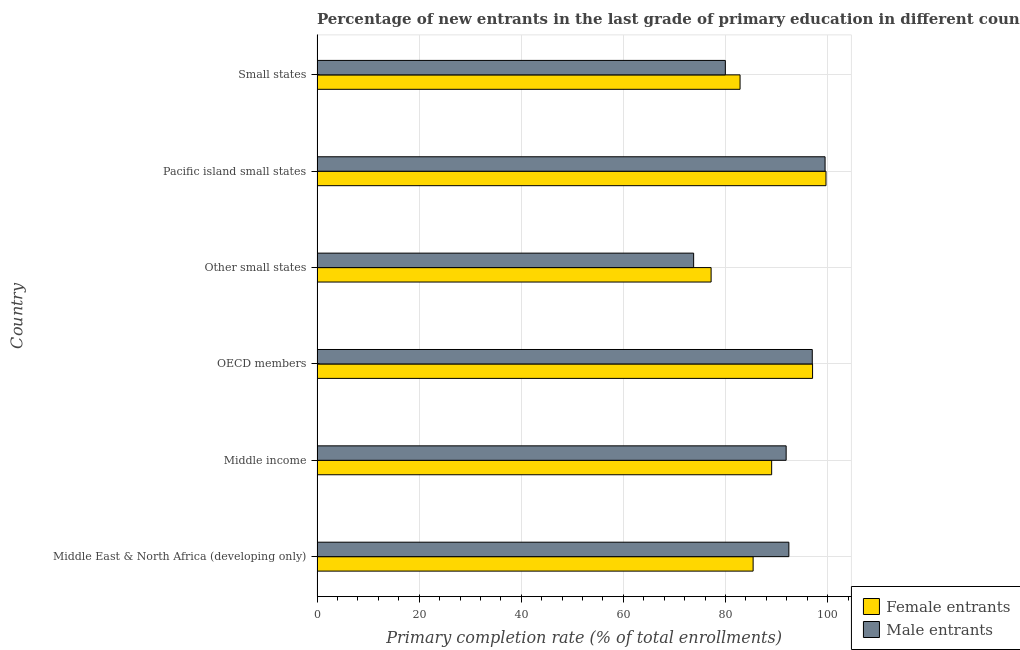How many groups of bars are there?
Provide a short and direct response. 6. How many bars are there on the 1st tick from the top?
Make the answer very short. 2. What is the label of the 3rd group of bars from the top?
Offer a very short reply. Other small states. What is the primary completion rate of male entrants in Small states?
Your response must be concise. 79.97. Across all countries, what is the maximum primary completion rate of male entrants?
Provide a short and direct response. 99.51. Across all countries, what is the minimum primary completion rate of male entrants?
Provide a succinct answer. 73.76. In which country was the primary completion rate of female entrants maximum?
Your response must be concise. Pacific island small states. In which country was the primary completion rate of female entrants minimum?
Make the answer very short. Other small states. What is the total primary completion rate of male entrants in the graph?
Give a very brief answer. 534.54. What is the difference between the primary completion rate of female entrants in Other small states and that in Pacific island small states?
Offer a terse response. -22.5. What is the difference between the primary completion rate of male entrants in Small states and the primary completion rate of female entrants in Middle East & North Africa (developing only)?
Provide a succinct answer. -5.44. What is the average primary completion rate of male entrants per country?
Provide a short and direct response. 89.09. What is the ratio of the primary completion rate of male entrants in Middle East & North Africa (developing only) to that in Small states?
Make the answer very short. 1.16. What is the difference between the highest and the second highest primary completion rate of female entrants?
Make the answer very short. 2.63. What is the difference between the highest and the lowest primary completion rate of female entrants?
Make the answer very short. 22.5. What does the 2nd bar from the top in OECD members represents?
Provide a short and direct response. Female entrants. What does the 2nd bar from the bottom in Other small states represents?
Provide a succinct answer. Male entrants. How many bars are there?
Your answer should be compact. 12. Are all the bars in the graph horizontal?
Your response must be concise. Yes. How many countries are there in the graph?
Provide a short and direct response. 6. Does the graph contain any zero values?
Give a very brief answer. No. Does the graph contain grids?
Keep it short and to the point. Yes. How many legend labels are there?
Offer a very short reply. 2. What is the title of the graph?
Ensure brevity in your answer.  Percentage of new entrants in the last grade of primary education in different countries. What is the label or title of the X-axis?
Your response must be concise. Primary completion rate (% of total enrollments). What is the label or title of the Y-axis?
Your answer should be compact. Country. What is the Primary completion rate (% of total enrollments) in Female entrants in Middle East & North Africa (developing only)?
Provide a succinct answer. 85.41. What is the Primary completion rate (% of total enrollments) of Male entrants in Middle East & North Africa (developing only)?
Provide a short and direct response. 92.41. What is the Primary completion rate (% of total enrollments) in Female entrants in Middle income?
Your answer should be compact. 89.04. What is the Primary completion rate (% of total enrollments) in Male entrants in Middle income?
Keep it short and to the point. 91.88. What is the Primary completion rate (% of total enrollments) of Female entrants in OECD members?
Keep it short and to the point. 97.05. What is the Primary completion rate (% of total enrollments) in Male entrants in OECD members?
Keep it short and to the point. 97. What is the Primary completion rate (% of total enrollments) of Female entrants in Other small states?
Offer a terse response. 77.18. What is the Primary completion rate (% of total enrollments) of Male entrants in Other small states?
Your answer should be compact. 73.76. What is the Primary completion rate (% of total enrollments) in Female entrants in Pacific island small states?
Offer a very short reply. 99.68. What is the Primary completion rate (% of total enrollments) of Male entrants in Pacific island small states?
Ensure brevity in your answer.  99.51. What is the Primary completion rate (% of total enrollments) of Female entrants in Small states?
Provide a short and direct response. 82.85. What is the Primary completion rate (% of total enrollments) of Male entrants in Small states?
Keep it short and to the point. 79.97. Across all countries, what is the maximum Primary completion rate (% of total enrollments) of Female entrants?
Give a very brief answer. 99.68. Across all countries, what is the maximum Primary completion rate (% of total enrollments) of Male entrants?
Offer a terse response. 99.51. Across all countries, what is the minimum Primary completion rate (% of total enrollments) in Female entrants?
Give a very brief answer. 77.18. Across all countries, what is the minimum Primary completion rate (% of total enrollments) of Male entrants?
Your answer should be very brief. 73.76. What is the total Primary completion rate (% of total enrollments) in Female entrants in the graph?
Your response must be concise. 531.23. What is the total Primary completion rate (% of total enrollments) in Male entrants in the graph?
Provide a short and direct response. 534.53. What is the difference between the Primary completion rate (% of total enrollments) of Female entrants in Middle East & North Africa (developing only) and that in Middle income?
Your response must be concise. -3.63. What is the difference between the Primary completion rate (% of total enrollments) in Male entrants in Middle East & North Africa (developing only) and that in Middle income?
Provide a short and direct response. 0.53. What is the difference between the Primary completion rate (% of total enrollments) in Female entrants in Middle East & North Africa (developing only) and that in OECD members?
Ensure brevity in your answer.  -11.64. What is the difference between the Primary completion rate (% of total enrollments) of Male entrants in Middle East & North Africa (developing only) and that in OECD members?
Give a very brief answer. -4.59. What is the difference between the Primary completion rate (% of total enrollments) in Female entrants in Middle East & North Africa (developing only) and that in Other small states?
Give a very brief answer. 8.23. What is the difference between the Primary completion rate (% of total enrollments) in Male entrants in Middle East & North Africa (developing only) and that in Other small states?
Ensure brevity in your answer.  18.65. What is the difference between the Primary completion rate (% of total enrollments) in Female entrants in Middle East & North Africa (developing only) and that in Pacific island small states?
Your answer should be very brief. -14.27. What is the difference between the Primary completion rate (% of total enrollments) of Male entrants in Middle East & North Africa (developing only) and that in Pacific island small states?
Provide a succinct answer. -7.09. What is the difference between the Primary completion rate (% of total enrollments) of Female entrants in Middle East & North Africa (developing only) and that in Small states?
Make the answer very short. 2.56. What is the difference between the Primary completion rate (% of total enrollments) in Male entrants in Middle East & North Africa (developing only) and that in Small states?
Provide a succinct answer. 12.44. What is the difference between the Primary completion rate (% of total enrollments) of Female entrants in Middle income and that in OECD members?
Provide a short and direct response. -8.01. What is the difference between the Primary completion rate (% of total enrollments) of Male entrants in Middle income and that in OECD members?
Your answer should be very brief. -5.12. What is the difference between the Primary completion rate (% of total enrollments) of Female entrants in Middle income and that in Other small states?
Give a very brief answer. 11.86. What is the difference between the Primary completion rate (% of total enrollments) in Male entrants in Middle income and that in Other small states?
Your answer should be compact. 18.12. What is the difference between the Primary completion rate (% of total enrollments) of Female entrants in Middle income and that in Pacific island small states?
Your answer should be very brief. -10.64. What is the difference between the Primary completion rate (% of total enrollments) in Male entrants in Middle income and that in Pacific island small states?
Keep it short and to the point. -7.62. What is the difference between the Primary completion rate (% of total enrollments) of Female entrants in Middle income and that in Small states?
Your response must be concise. 6.19. What is the difference between the Primary completion rate (% of total enrollments) of Male entrants in Middle income and that in Small states?
Give a very brief answer. 11.91. What is the difference between the Primary completion rate (% of total enrollments) of Female entrants in OECD members and that in Other small states?
Your answer should be very brief. 19.87. What is the difference between the Primary completion rate (% of total enrollments) of Male entrants in OECD members and that in Other small states?
Provide a succinct answer. 23.24. What is the difference between the Primary completion rate (% of total enrollments) of Female entrants in OECD members and that in Pacific island small states?
Your answer should be very brief. -2.63. What is the difference between the Primary completion rate (% of total enrollments) in Male entrants in OECD members and that in Pacific island small states?
Give a very brief answer. -2.51. What is the difference between the Primary completion rate (% of total enrollments) in Female entrants in OECD members and that in Small states?
Provide a succinct answer. 14.2. What is the difference between the Primary completion rate (% of total enrollments) of Male entrants in OECD members and that in Small states?
Your response must be concise. 17.03. What is the difference between the Primary completion rate (% of total enrollments) of Female entrants in Other small states and that in Pacific island small states?
Your answer should be compact. -22.5. What is the difference between the Primary completion rate (% of total enrollments) in Male entrants in Other small states and that in Pacific island small states?
Offer a terse response. -25.74. What is the difference between the Primary completion rate (% of total enrollments) of Female entrants in Other small states and that in Small states?
Offer a very short reply. -5.67. What is the difference between the Primary completion rate (% of total enrollments) in Male entrants in Other small states and that in Small states?
Your answer should be very brief. -6.21. What is the difference between the Primary completion rate (% of total enrollments) in Female entrants in Pacific island small states and that in Small states?
Provide a short and direct response. 16.83. What is the difference between the Primary completion rate (% of total enrollments) of Male entrants in Pacific island small states and that in Small states?
Your answer should be compact. 19.54. What is the difference between the Primary completion rate (% of total enrollments) in Female entrants in Middle East & North Africa (developing only) and the Primary completion rate (% of total enrollments) in Male entrants in Middle income?
Ensure brevity in your answer.  -6.47. What is the difference between the Primary completion rate (% of total enrollments) of Female entrants in Middle East & North Africa (developing only) and the Primary completion rate (% of total enrollments) of Male entrants in OECD members?
Your answer should be very brief. -11.59. What is the difference between the Primary completion rate (% of total enrollments) of Female entrants in Middle East & North Africa (developing only) and the Primary completion rate (% of total enrollments) of Male entrants in Other small states?
Your answer should be very brief. 11.65. What is the difference between the Primary completion rate (% of total enrollments) of Female entrants in Middle East & North Africa (developing only) and the Primary completion rate (% of total enrollments) of Male entrants in Pacific island small states?
Give a very brief answer. -14.09. What is the difference between the Primary completion rate (% of total enrollments) in Female entrants in Middle East & North Africa (developing only) and the Primary completion rate (% of total enrollments) in Male entrants in Small states?
Your answer should be compact. 5.44. What is the difference between the Primary completion rate (% of total enrollments) in Female entrants in Middle income and the Primary completion rate (% of total enrollments) in Male entrants in OECD members?
Ensure brevity in your answer.  -7.96. What is the difference between the Primary completion rate (% of total enrollments) of Female entrants in Middle income and the Primary completion rate (% of total enrollments) of Male entrants in Other small states?
Make the answer very short. 15.28. What is the difference between the Primary completion rate (% of total enrollments) of Female entrants in Middle income and the Primary completion rate (% of total enrollments) of Male entrants in Pacific island small states?
Make the answer very short. -10.47. What is the difference between the Primary completion rate (% of total enrollments) in Female entrants in Middle income and the Primary completion rate (% of total enrollments) in Male entrants in Small states?
Offer a terse response. 9.07. What is the difference between the Primary completion rate (% of total enrollments) in Female entrants in OECD members and the Primary completion rate (% of total enrollments) in Male entrants in Other small states?
Provide a short and direct response. 23.29. What is the difference between the Primary completion rate (% of total enrollments) in Female entrants in OECD members and the Primary completion rate (% of total enrollments) in Male entrants in Pacific island small states?
Provide a short and direct response. -2.45. What is the difference between the Primary completion rate (% of total enrollments) in Female entrants in OECD members and the Primary completion rate (% of total enrollments) in Male entrants in Small states?
Provide a succinct answer. 17.08. What is the difference between the Primary completion rate (% of total enrollments) in Female entrants in Other small states and the Primary completion rate (% of total enrollments) in Male entrants in Pacific island small states?
Give a very brief answer. -22.32. What is the difference between the Primary completion rate (% of total enrollments) of Female entrants in Other small states and the Primary completion rate (% of total enrollments) of Male entrants in Small states?
Your answer should be compact. -2.79. What is the difference between the Primary completion rate (% of total enrollments) in Female entrants in Pacific island small states and the Primary completion rate (% of total enrollments) in Male entrants in Small states?
Offer a terse response. 19.71. What is the average Primary completion rate (% of total enrollments) in Female entrants per country?
Your answer should be compact. 88.54. What is the average Primary completion rate (% of total enrollments) of Male entrants per country?
Your answer should be compact. 89.09. What is the difference between the Primary completion rate (% of total enrollments) of Female entrants and Primary completion rate (% of total enrollments) of Male entrants in Middle income?
Make the answer very short. -2.84. What is the difference between the Primary completion rate (% of total enrollments) of Female entrants and Primary completion rate (% of total enrollments) of Male entrants in OECD members?
Your answer should be very brief. 0.05. What is the difference between the Primary completion rate (% of total enrollments) in Female entrants and Primary completion rate (% of total enrollments) in Male entrants in Other small states?
Make the answer very short. 3.42. What is the difference between the Primary completion rate (% of total enrollments) in Female entrants and Primary completion rate (% of total enrollments) in Male entrants in Pacific island small states?
Your answer should be very brief. 0.18. What is the difference between the Primary completion rate (% of total enrollments) in Female entrants and Primary completion rate (% of total enrollments) in Male entrants in Small states?
Your answer should be very brief. 2.88. What is the ratio of the Primary completion rate (% of total enrollments) of Female entrants in Middle East & North Africa (developing only) to that in Middle income?
Make the answer very short. 0.96. What is the ratio of the Primary completion rate (% of total enrollments) in Male entrants in Middle East & North Africa (developing only) to that in Middle income?
Offer a terse response. 1.01. What is the ratio of the Primary completion rate (% of total enrollments) of Female entrants in Middle East & North Africa (developing only) to that in OECD members?
Your answer should be very brief. 0.88. What is the ratio of the Primary completion rate (% of total enrollments) of Male entrants in Middle East & North Africa (developing only) to that in OECD members?
Keep it short and to the point. 0.95. What is the ratio of the Primary completion rate (% of total enrollments) of Female entrants in Middle East & North Africa (developing only) to that in Other small states?
Your answer should be compact. 1.11. What is the ratio of the Primary completion rate (% of total enrollments) in Male entrants in Middle East & North Africa (developing only) to that in Other small states?
Offer a terse response. 1.25. What is the ratio of the Primary completion rate (% of total enrollments) of Female entrants in Middle East & North Africa (developing only) to that in Pacific island small states?
Ensure brevity in your answer.  0.86. What is the ratio of the Primary completion rate (% of total enrollments) of Male entrants in Middle East & North Africa (developing only) to that in Pacific island small states?
Your answer should be compact. 0.93. What is the ratio of the Primary completion rate (% of total enrollments) of Female entrants in Middle East & North Africa (developing only) to that in Small states?
Ensure brevity in your answer.  1.03. What is the ratio of the Primary completion rate (% of total enrollments) of Male entrants in Middle East & North Africa (developing only) to that in Small states?
Your response must be concise. 1.16. What is the ratio of the Primary completion rate (% of total enrollments) in Female entrants in Middle income to that in OECD members?
Your answer should be very brief. 0.92. What is the ratio of the Primary completion rate (% of total enrollments) of Male entrants in Middle income to that in OECD members?
Your response must be concise. 0.95. What is the ratio of the Primary completion rate (% of total enrollments) of Female entrants in Middle income to that in Other small states?
Provide a short and direct response. 1.15. What is the ratio of the Primary completion rate (% of total enrollments) of Male entrants in Middle income to that in Other small states?
Provide a succinct answer. 1.25. What is the ratio of the Primary completion rate (% of total enrollments) in Female entrants in Middle income to that in Pacific island small states?
Keep it short and to the point. 0.89. What is the ratio of the Primary completion rate (% of total enrollments) of Male entrants in Middle income to that in Pacific island small states?
Your response must be concise. 0.92. What is the ratio of the Primary completion rate (% of total enrollments) of Female entrants in Middle income to that in Small states?
Make the answer very short. 1.07. What is the ratio of the Primary completion rate (% of total enrollments) of Male entrants in Middle income to that in Small states?
Offer a terse response. 1.15. What is the ratio of the Primary completion rate (% of total enrollments) of Female entrants in OECD members to that in Other small states?
Your response must be concise. 1.26. What is the ratio of the Primary completion rate (% of total enrollments) of Male entrants in OECD members to that in Other small states?
Your response must be concise. 1.31. What is the ratio of the Primary completion rate (% of total enrollments) in Female entrants in OECD members to that in Pacific island small states?
Your answer should be compact. 0.97. What is the ratio of the Primary completion rate (% of total enrollments) of Male entrants in OECD members to that in Pacific island small states?
Your answer should be very brief. 0.97. What is the ratio of the Primary completion rate (% of total enrollments) in Female entrants in OECD members to that in Small states?
Make the answer very short. 1.17. What is the ratio of the Primary completion rate (% of total enrollments) of Male entrants in OECD members to that in Small states?
Offer a very short reply. 1.21. What is the ratio of the Primary completion rate (% of total enrollments) in Female entrants in Other small states to that in Pacific island small states?
Make the answer very short. 0.77. What is the ratio of the Primary completion rate (% of total enrollments) of Male entrants in Other small states to that in Pacific island small states?
Your response must be concise. 0.74. What is the ratio of the Primary completion rate (% of total enrollments) of Female entrants in Other small states to that in Small states?
Provide a succinct answer. 0.93. What is the ratio of the Primary completion rate (% of total enrollments) of Male entrants in Other small states to that in Small states?
Ensure brevity in your answer.  0.92. What is the ratio of the Primary completion rate (% of total enrollments) of Female entrants in Pacific island small states to that in Small states?
Give a very brief answer. 1.2. What is the ratio of the Primary completion rate (% of total enrollments) of Male entrants in Pacific island small states to that in Small states?
Ensure brevity in your answer.  1.24. What is the difference between the highest and the second highest Primary completion rate (% of total enrollments) in Female entrants?
Your response must be concise. 2.63. What is the difference between the highest and the second highest Primary completion rate (% of total enrollments) in Male entrants?
Keep it short and to the point. 2.51. What is the difference between the highest and the lowest Primary completion rate (% of total enrollments) of Female entrants?
Your response must be concise. 22.5. What is the difference between the highest and the lowest Primary completion rate (% of total enrollments) of Male entrants?
Make the answer very short. 25.74. 